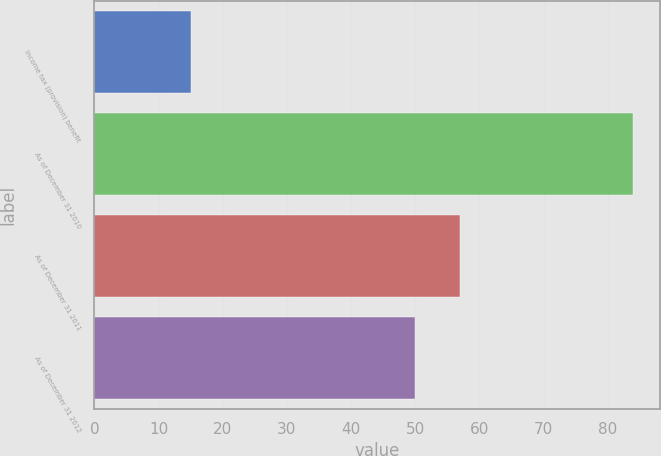Convert chart. <chart><loc_0><loc_0><loc_500><loc_500><bar_chart><fcel>Income tax (provision) benefit<fcel>As of December 31 2010<fcel>As of December 31 2011<fcel>As of December 31 2012<nl><fcel>15<fcel>84<fcel>57<fcel>50<nl></chart> 